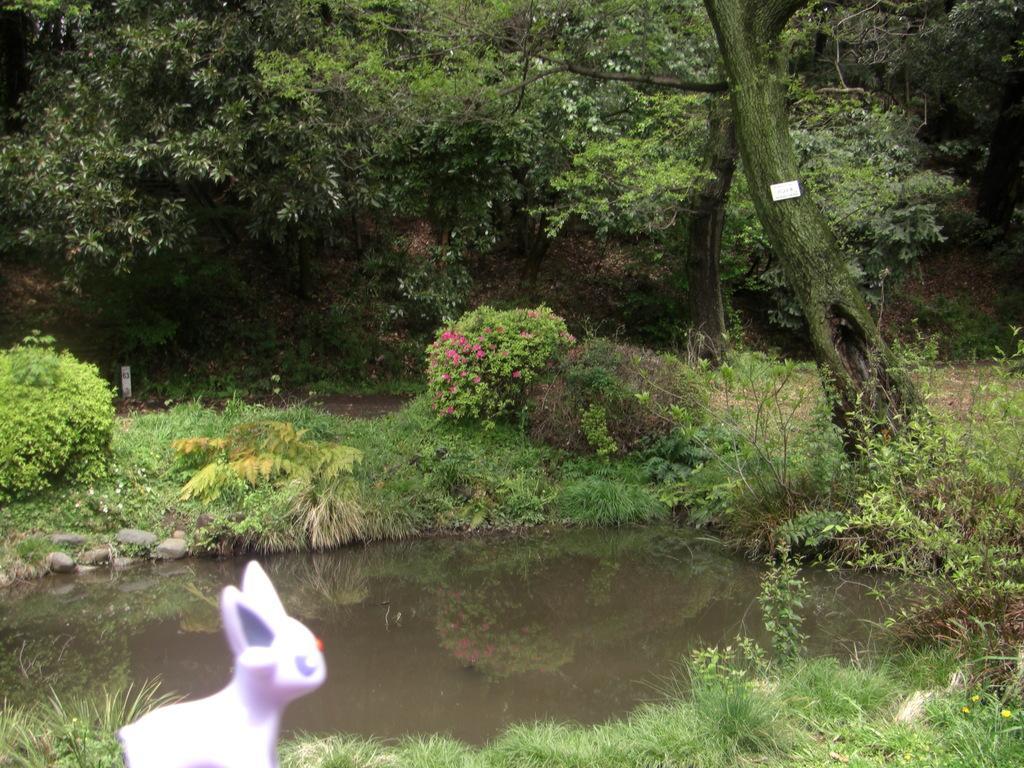Please provide a concise description of this image. There is a toy, grass, water, floral plants and trees. 